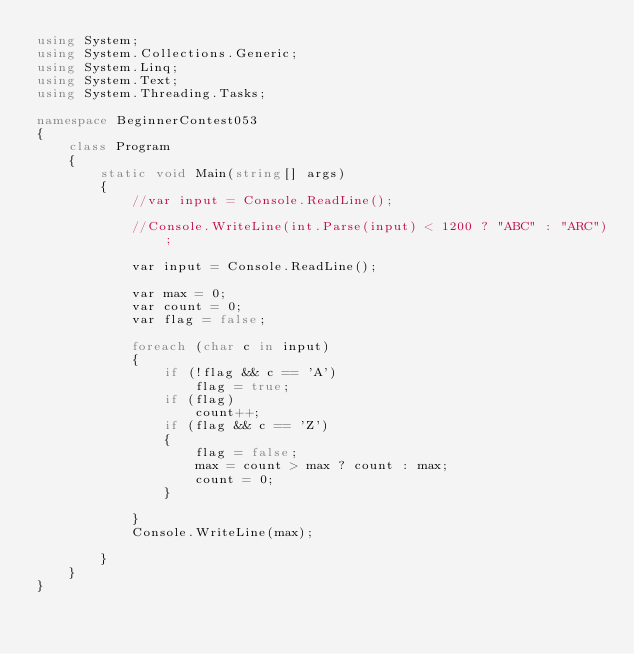<code> <loc_0><loc_0><loc_500><loc_500><_C#_>using System;
using System.Collections.Generic;
using System.Linq;
using System.Text;
using System.Threading.Tasks;

namespace BeginnerContest053
{
    class Program
    {
        static void Main(string[] args)
        {
            //var input = Console.ReadLine();                                                   

            //Console.WriteLine(int.Parse(input) < 1200 ? "ABC" : "ARC");

            var input = Console.ReadLine();

            var max = 0;
            var count = 0;
            var flag = false;

            foreach (char c in input)
            {
                if (!flag && c == 'A')
                    flag = true;
                if (flag)
                    count++;
                if (flag && c == 'Z')
                {
                    flag = false;
                    max = count > max ? count : max;
                    count = 0;
                }
                    
            }
            Console.WriteLine(max);

        }
    }
}
</code> 